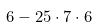<formula> <loc_0><loc_0><loc_500><loc_500>6 - 2 5 \cdot 7 \cdot 6</formula> 